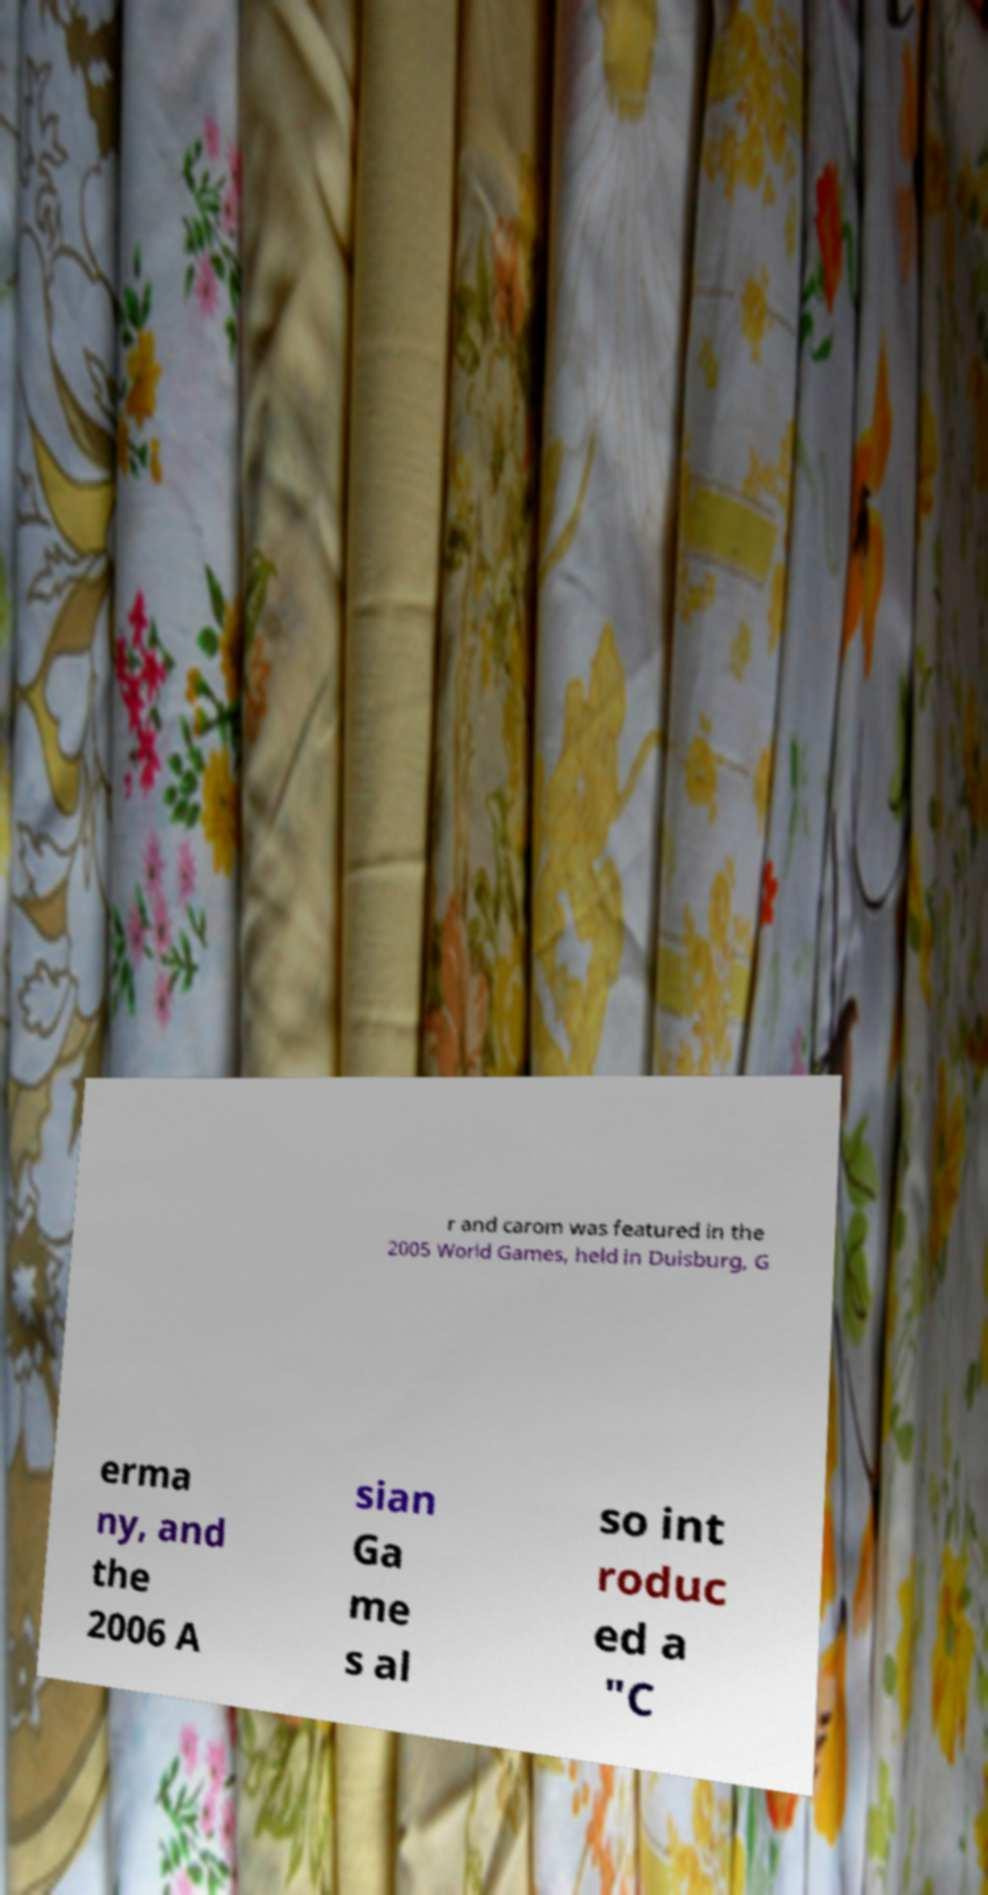I need the written content from this picture converted into text. Can you do that? r and carom was featured in the 2005 World Games, held in Duisburg, G erma ny, and the 2006 A sian Ga me s al so int roduc ed a "C 